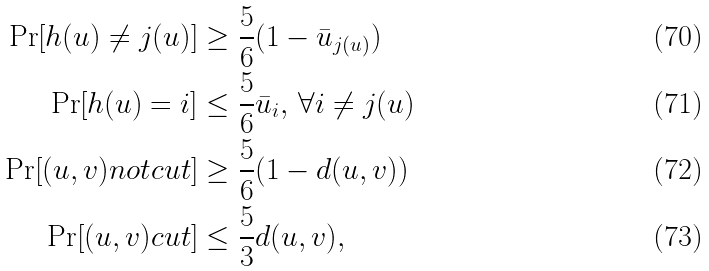<formula> <loc_0><loc_0><loc_500><loc_500>\Pr [ h ( u ) \ne j ( u ) ] & \geq \frac { 5 } { 6 } ( 1 - \bar { u } _ { j ( u ) } ) \\ \Pr [ h ( u ) = i ] & \leq \frac { 5 } { 6 } \bar { u } _ { i } , \, \forall i \ne j ( u ) \\ \Pr [ ( u , v ) n o t c u t ] & \geq \frac { 5 } { 6 } ( 1 - d ( u , v ) ) \\ \Pr [ ( u , v ) c u t ] & \leq \frac { 5 } { 3 } d ( u , v ) ,</formula> 